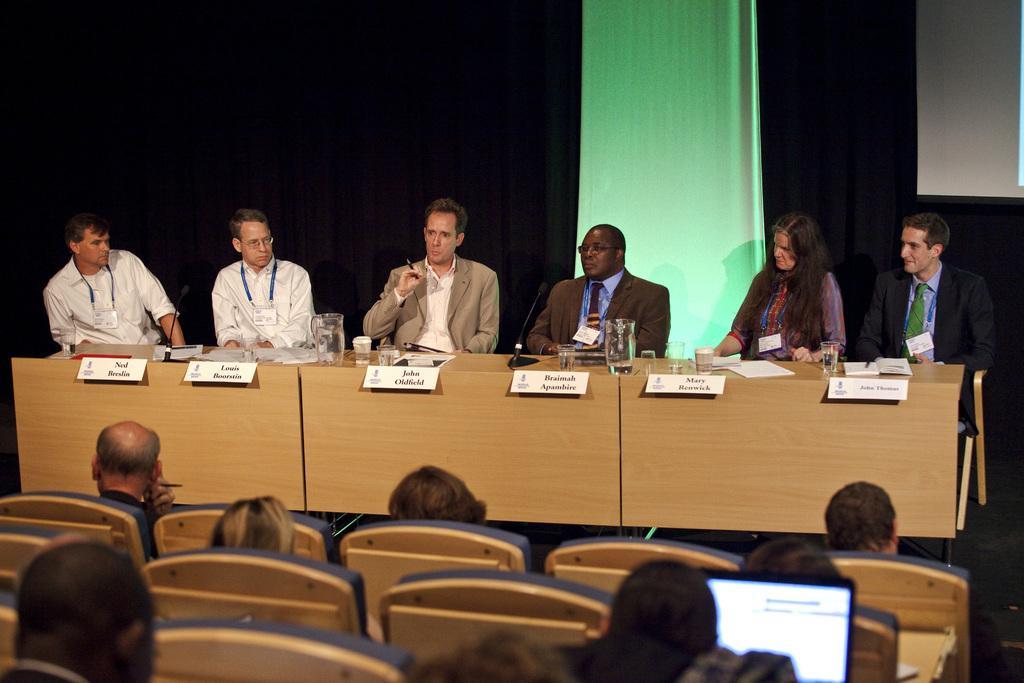Could you give a brief overview of what you see in this image? In the picture there are people sitting on the chair with the table in front of them, on the table there are jugs present, there are nameplates present, there are papers, there are microphones present, there are glasses with the liquid, there is a curtain behind them, in front of them there are people sitting on the chairs. 